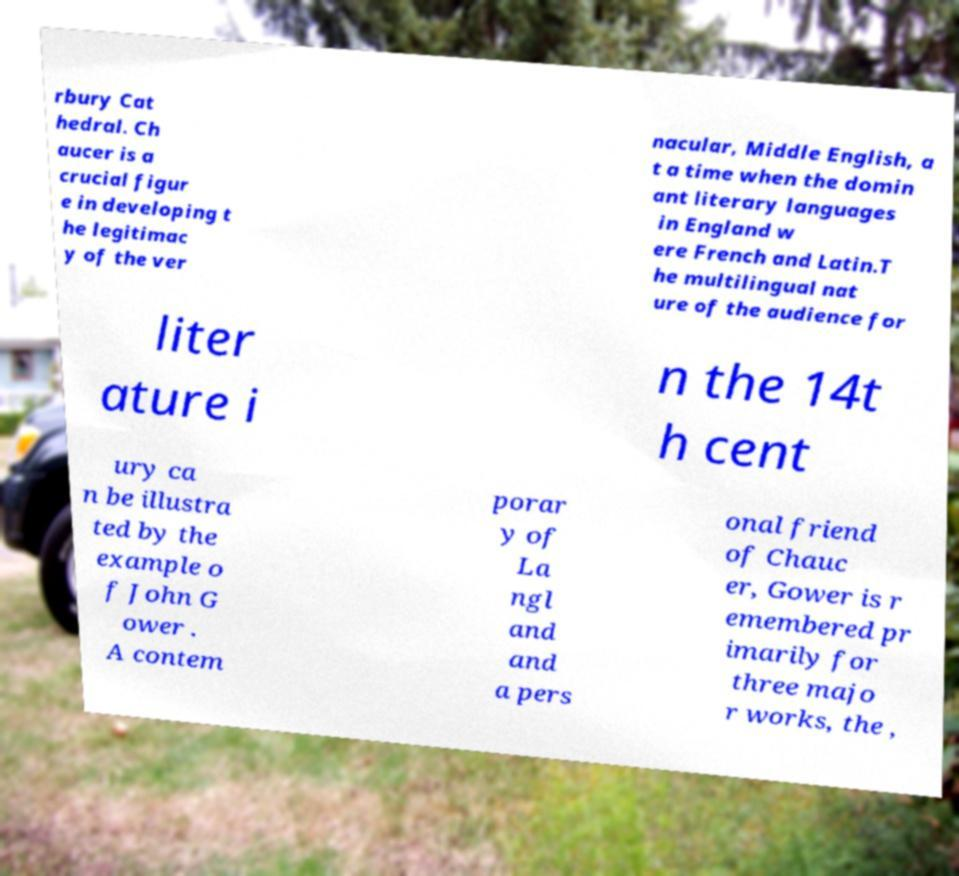Can you accurately transcribe the text from the provided image for me? rbury Cat hedral. Ch aucer is a crucial figur e in developing t he legitimac y of the ver nacular, Middle English, a t a time when the domin ant literary languages in England w ere French and Latin.T he multilingual nat ure of the audience for liter ature i n the 14t h cent ury ca n be illustra ted by the example o f John G ower . A contem porar y of La ngl and and a pers onal friend of Chauc er, Gower is r emembered pr imarily for three majo r works, the , 